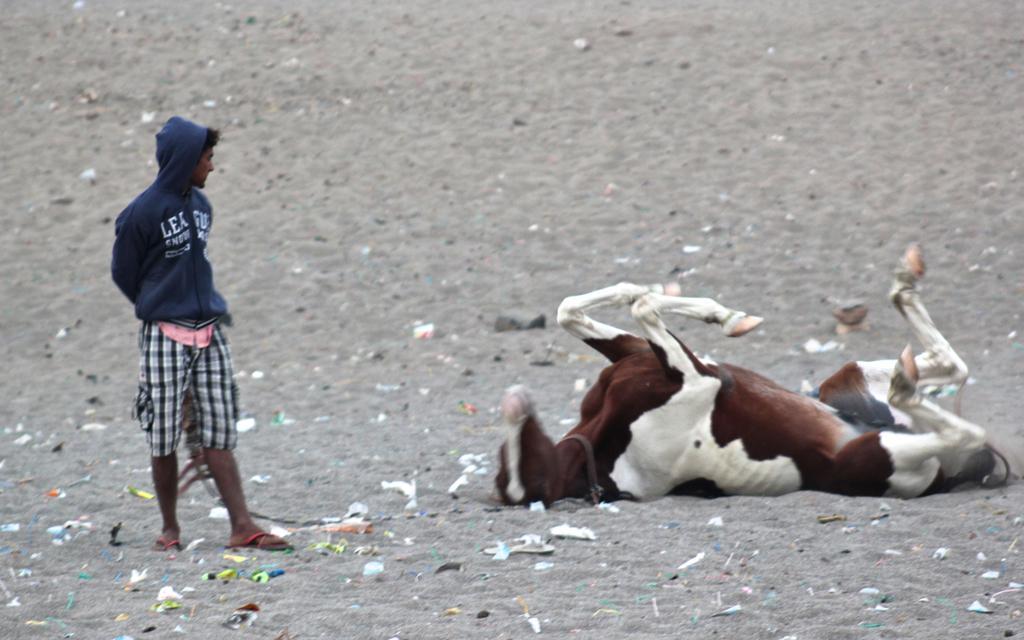Could you give a brief overview of what you see in this image? In this image we can see a horse. There is a person. At the bottom of the image there is sand. 